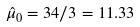Convert formula to latex. <formula><loc_0><loc_0><loc_500><loc_500>\hat { \mu } _ { 0 } = 3 4 / 3 = 1 1 . 3 3</formula> 